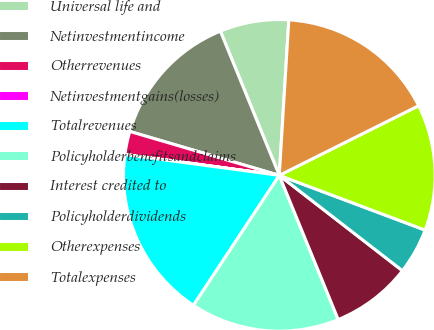Convert chart. <chart><loc_0><loc_0><loc_500><loc_500><pie_chart><fcel>Universal life and<fcel>Netinvestmentincome<fcel>Otherrevenues<fcel>Netinvestmentgains(losses)<fcel>Totalrevenues<fcel>Policyholderbenefitsandclaims<fcel>Interest credited to<fcel>Policyholderdividends<fcel>Otherexpenses<fcel>Totalexpenses<nl><fcel>7.15%<fcel>14.28%<fcel>2.4%<fcel>0.02%<fcel>17.84%<fcel>15.46%<fcel>8.34%<fcel>4.77%<fcel>13.09%<fcel>16.65%<nl></chart> 